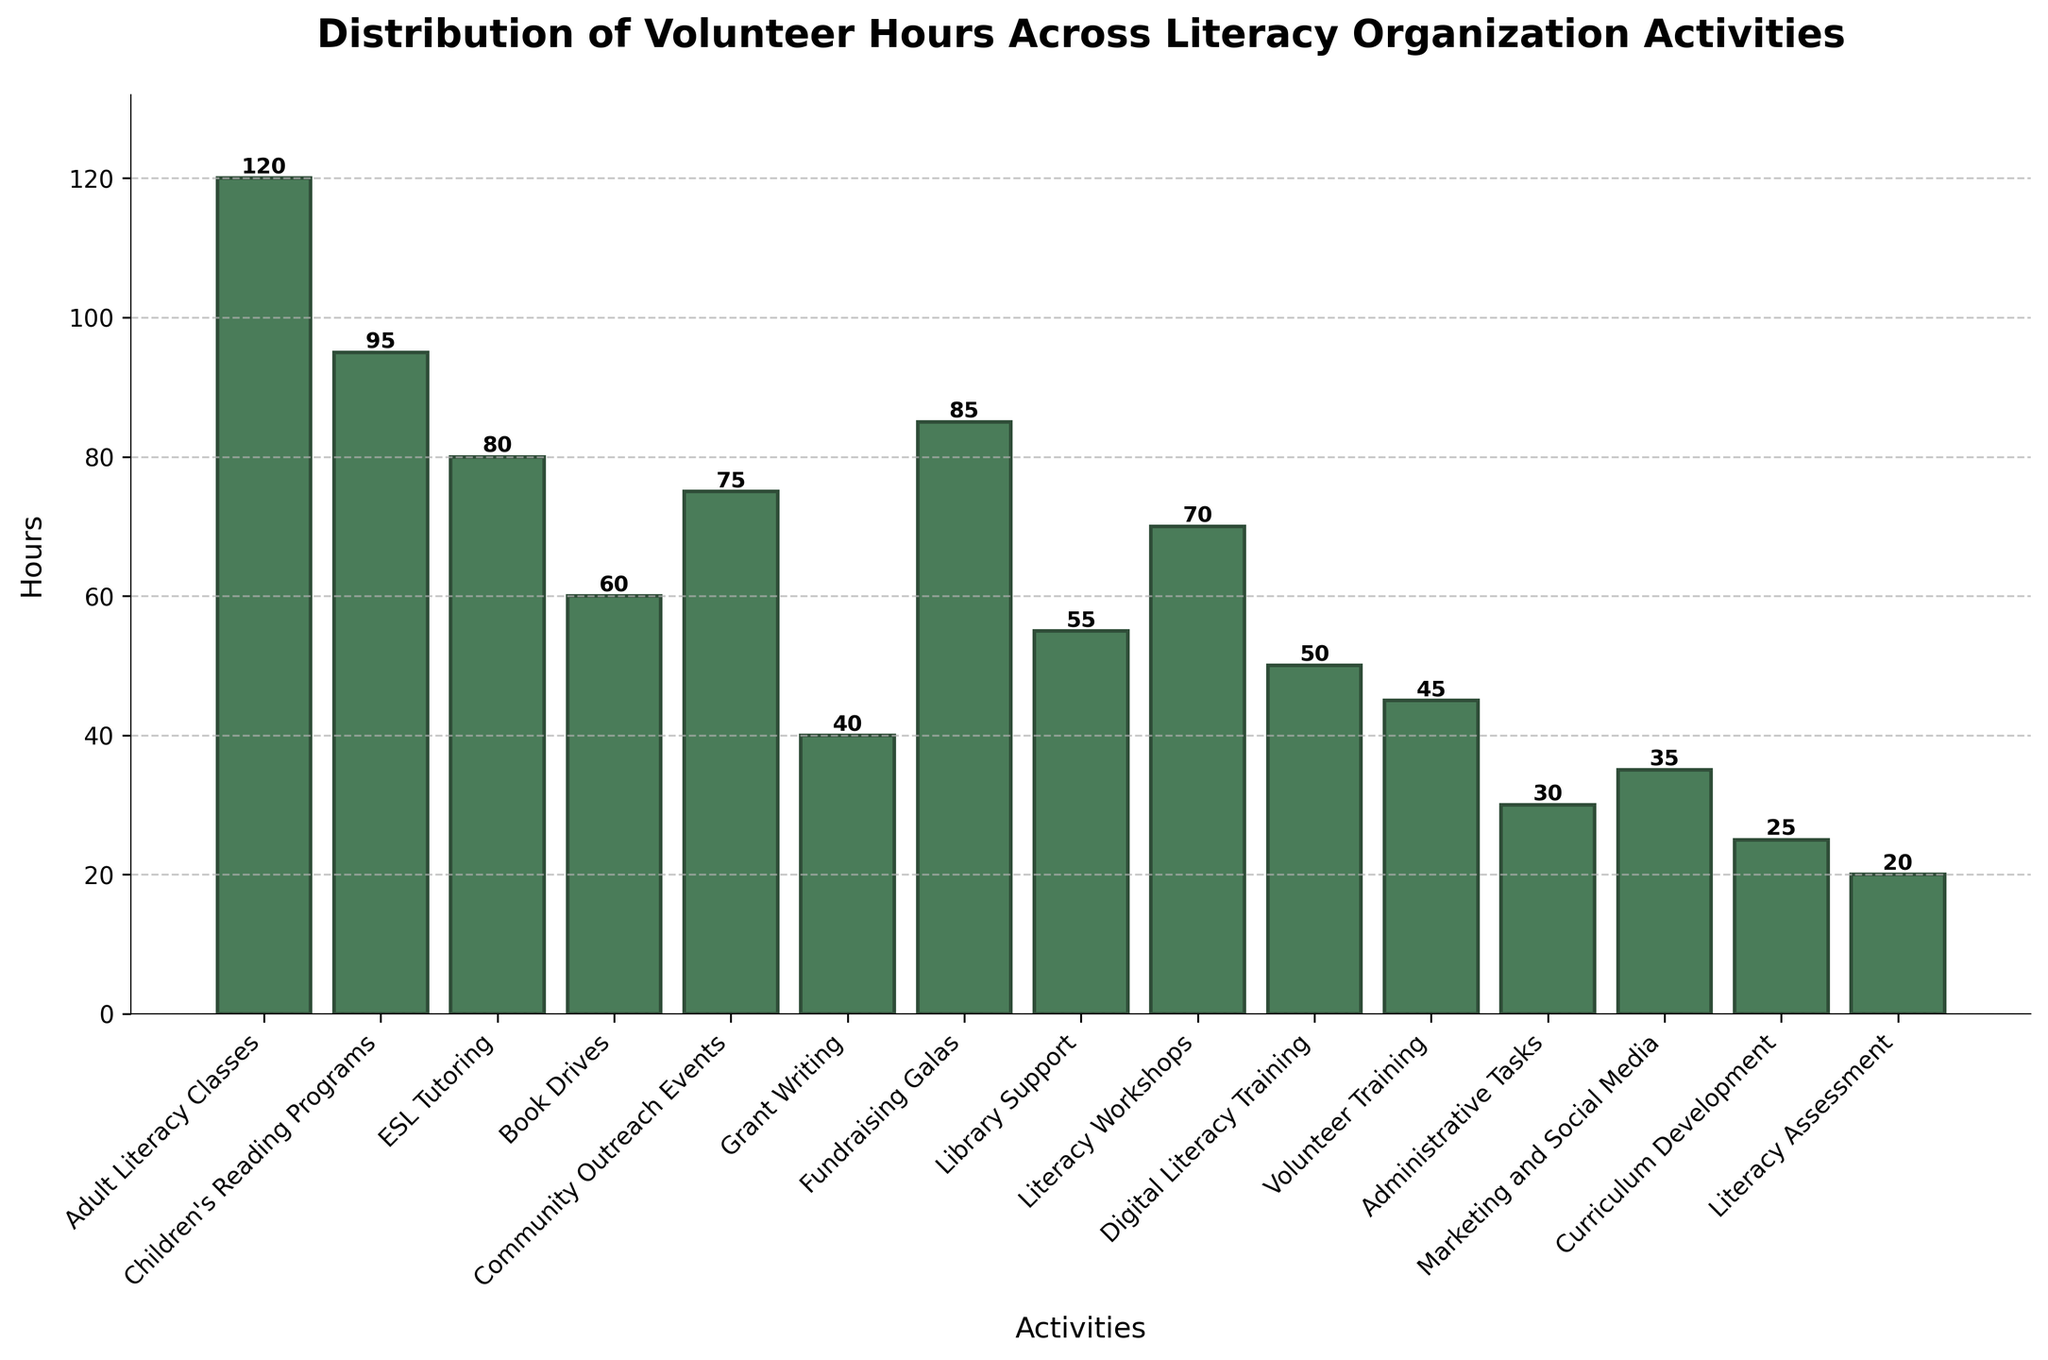Which activity had the most volunteer hours? Referencing the figure, check which bar reaches the highest point on the y-axis, representing the number of hours. The tallest bar corresponds to the activity with the most hours.
Answer: Adult Literacy Classes Which activity had the least volunteer hours? Look for the bar that barely rises above the x-axis, indicating the fewest hours. This will be the shortest bar.
Answer: Literacy Assessment How many total volunteer hours were dedicated to Fundraising Galas and Community Outreach Events combined? Sum the hours for Fundraising Galas (85) and Community Outreach Events (75). 85 + 75 = 160
Answer: 160 Are the hours for Digital Literacy Training greater than the hours for Library Support? Compare the heights of the bars for Digital Literacy Training (50) and Library Support (55). Note which is higher.
Answer: No Which three activities had volunteer hours closest to 50? Identify the activities with hours near 50 by checking the bar heights around this value. Digital Literacy Training (50), Volunteer Training (45), and Marketing and Social Media (35) are the nearest.
Answer: Digital Literacy Training, Volunteer Training, Marketing and Social Media How many hours more were dedicated to Adult Literacy Classes compared to Literacy Assessment? Subtract hours for Literacy Assessment (20) from Adult Literacy Classes (120). 120 - 20 = 100
Answer: 100 Which has more volunteer hours, ESL Tutoring or Fundraising Galas? Compare the heights of the bars for ESL Tutoring (80) and Fundraising Galas (85).
Answer: Fundraising Galas What is the average number of volunteer hours across all activities? Add up the hours across all activities and divide by the number of activities. Total is 885 hours (120+95+80+60+75+40+85+55+70+50+45+30+35+25+20), and there are 15 activities. 885/15 = 59
Answer: 59 Is the bar for Grant Writing taller than the bar for Administrative Tasks? Check if the bar for Grant Writing (40) is visually taller than the bar for Administrative Tasks (30).
Answer: Yes Which activities have volunteer hours between 40 and 70? Identify the bars whose heights correspond to the range between 40 and 70 hours. Grant Writing (40), Volunteer Training (45), Marketing and Social Media (35), and Literacy Workshops (70) fall in this range.
Answer: Grant Writing, Volunteer Training, Literacy Workshops 